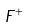<formula> <loc_0><loc_0><loc_500><loc_500>F ^ { + }</formula> 